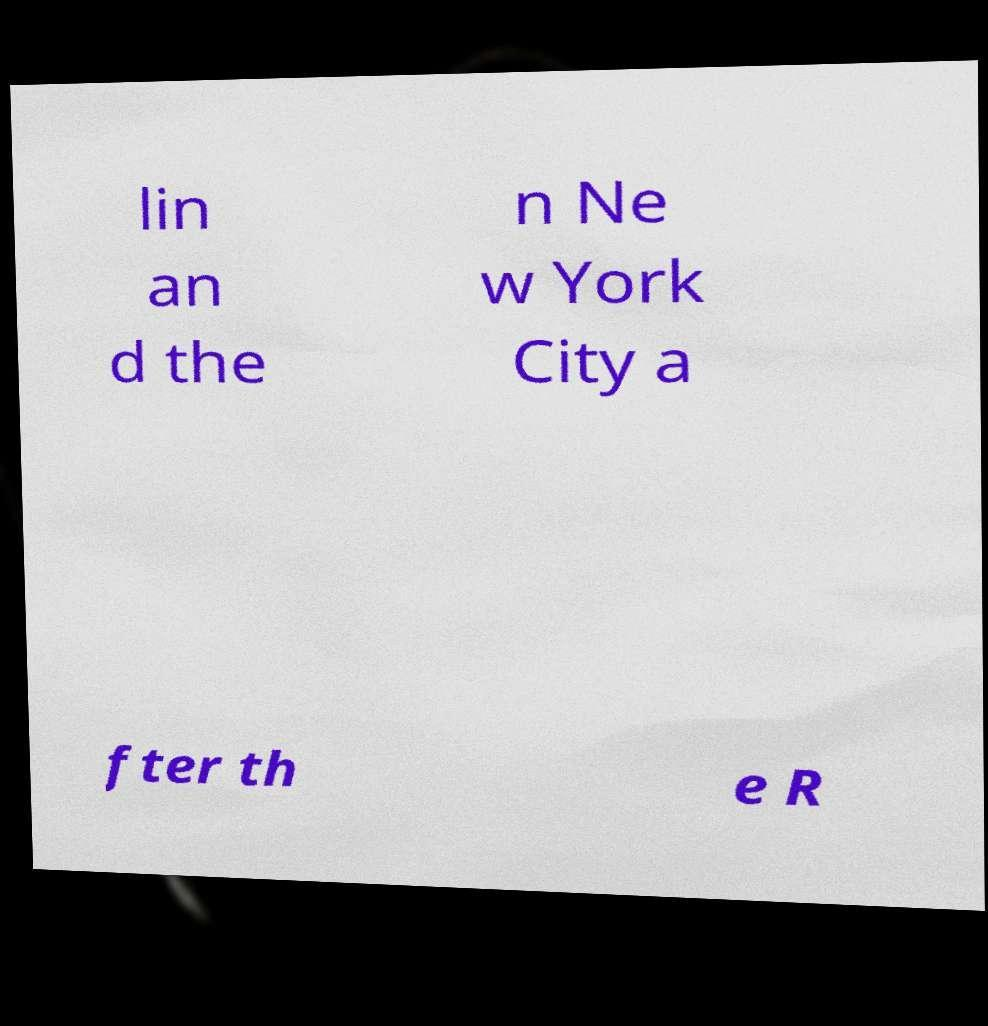For documentation purposes, I need the text within this image transcribed. Could you provide that? lin an d the n Ne w York City a fter th e R 